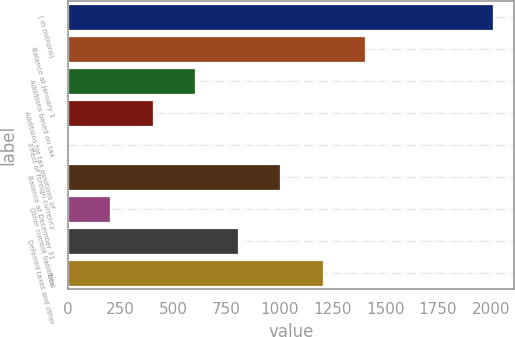Convert chart. <chart><loc_0><loc_0><loc_500><loc_500><bar_chart><fcel>( in millions)<fcel>Balance at January 1<fcel>Additions based on tax<fcel>Additions for tax positions of<fcel>Effect of foreign currency<fcel>Balance at December 31<fcel>Other current liabilities<fcel>Deferred taxes and other<fcel>Total<nl><fcel>2009<fcel>1406.39<fcel>602.91<fcel>402.04<fcel>0.3<fcel>1004.65<fcel>201.17<fcel>803.78<fcel>1205.52<nl></chart> 